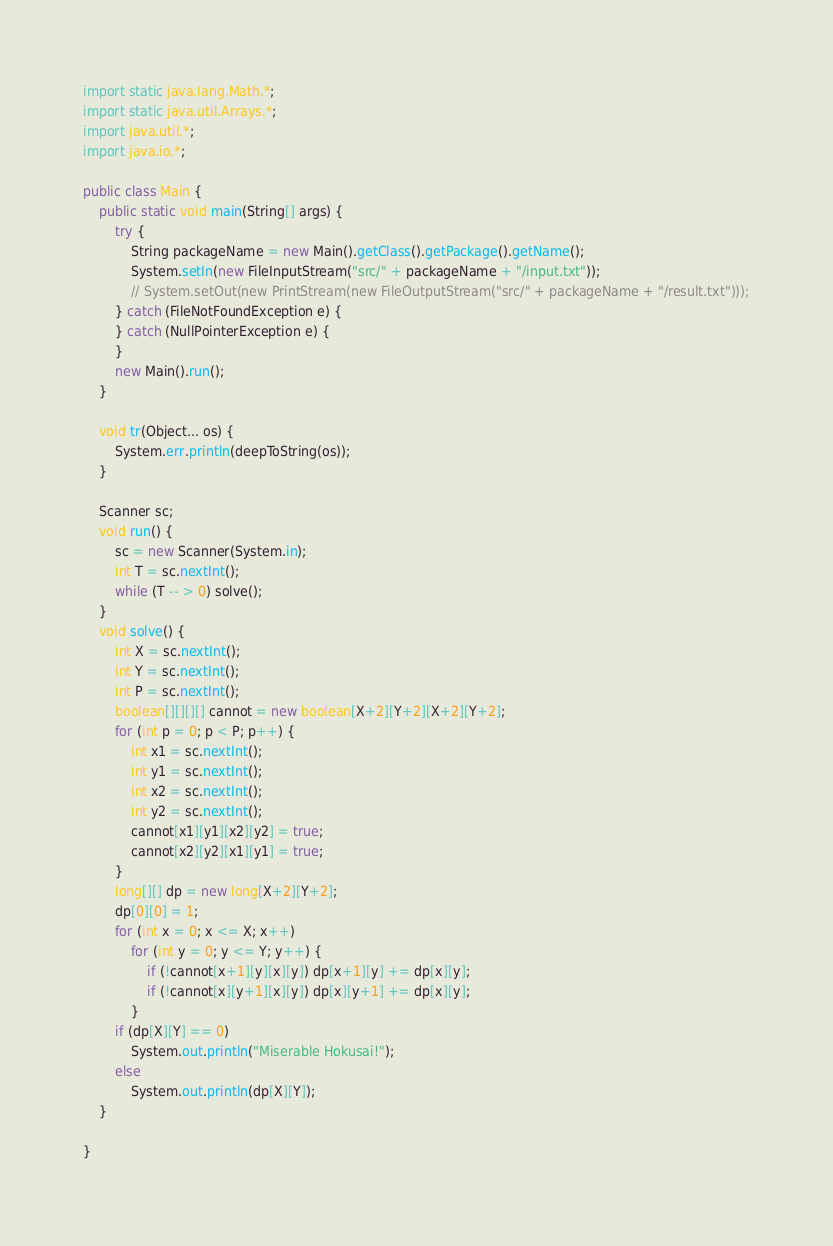Convert code to text. <code><loc_0><loc_0><loc_500><loc_500><_Java_>import static java.lang.Math.*;
import static java.util.Arrays.*;
import java.util.*;
import java.io.*;

public class Main {
	public static void main(String[] args) {
		try {
			String packageName = new Main().getClass().getPackage().getName();
			System.setIn(new FileInputStream("src/" + packageName + "/input.txt"));
			// System.setOut(new PrintStream(new FileOutputStream("src/" + packageName + "/result.txt")));
		} catch (FileNotFoundException e) {
		} catch (NullPointerException e) {
		}
		new Main().run();
	}

	void tr(Object... os) {
		System.err.println(deepToString(os));
	}

	Scanner sc;
	void run() {
		sc = new Scanner(System.in);
		int T = sc.nextInt();
		while (T -- > 0) solve();
	}
	void solve() {
		int X = sc.nextInt();
		int Y = sc.nextInt();
		int P = sc.nextInt();
		boolean[][][][] cannot = new boolean[X+2][Y+2][X+2][Y+2];
		for (int p = 0; p < P; p++) {
			int x1 = sc.nextInt();
			int y1 = sc.nextInt();
			int x2 = sc.nextInt();
			int y2 = sc.nextInt();
			cannot[x1][y1][x2][y2] = true;
			cannot[x2][y2][x1][y1] = true;
		}
		long[][] dp = new long[X+2][Y+2];
		dp[0][0] = 1;
		for (int x = 0; x <= X; x++)
			for (int y = 0; y <= Y; y++) {
				if (!cannot[x+1][y][x][y]) dp[x+1][y] += dp[x][y];
				if (!cannot[x][y+1][x][y]) dp[x][y+1] += dp[x][y];
			}
		if (dp[X][Y] == 0)
			System.out.println("Miserable Hokusai!");
		else
			System.out.println(dp[X][Y]);
	}

}</code> 